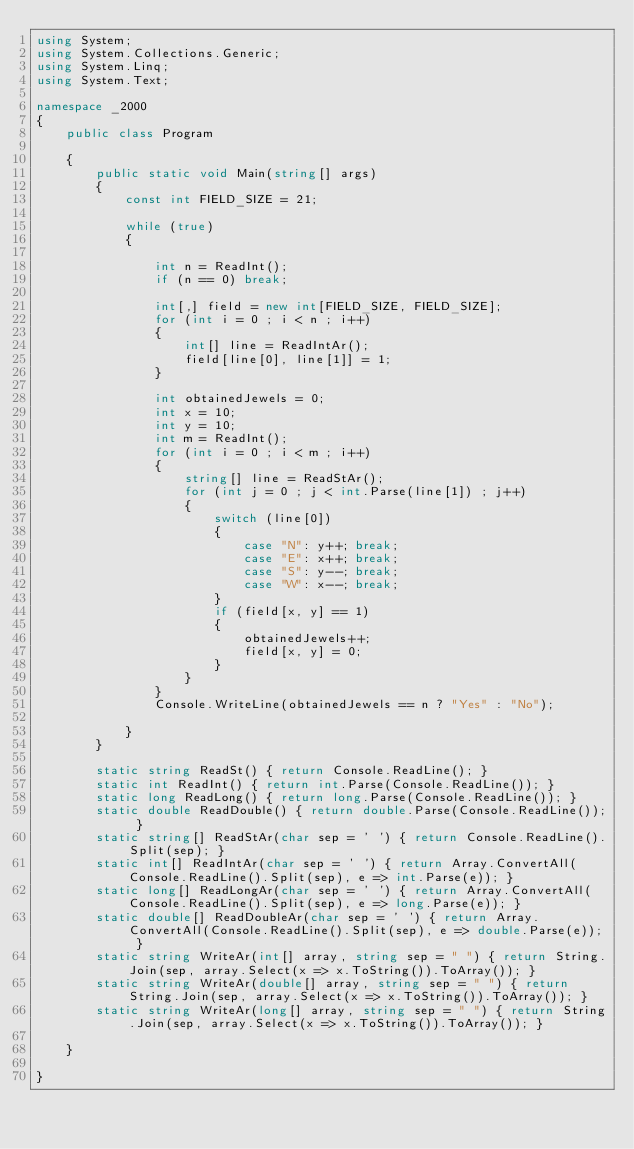Convert code to text. <code><loc_0><loc_0><loc_500><loc_500><_C#_>using System;
using System.Collections.Generic;
using System.Linq;
using System.Text;

namespace _2000
{
    public class Program

    {
        public static void Main(string[] args)
        {
            const int FIELD_SIZE = 21;

            while (true)
            {

                int n = ReadInt();
                if (n == 0) break;

                int[,] field = new int[FIELD_SIZE, FIELD_SIZE];
                for (int i = 0 ; i < n ; i++)
                {
                    int[] line = ReadIntAr();
                    field[line[0], line[1]] = 1;
                }

                int obtainedJewels = 0;
                int x = 10;
                int y = 10;
                int m = ReadInt();
                for (int i = 0 ; i < m ; i++)
                {
                    string[] line = ReadStAr();
                    for (int j = 0 ; j < int.Parse(line[1]) ; j++)
                    {
                        switch (line[0])
                        {
                            case "N": y++; break;
                            case "E": x++; break;
                            case "S": y--; break;
                            case "W": x--; break;
                        }
                        if (field[x, y] == 1)
                        {
                            obtainedJewels++;
                            field[x, y] = 0;
                        }
                    }
                }
                Console.WriteLine(obtainedJewels == n ? "Yes" : "No");

            }
        }

        static string ReadSt() { return Console.ReadLine(); }
        static int ReadInt() { return int.Parse(Console.ReadLine()); }
        static long ReadLong() { return long.Parse(Console.ReadLine()); }
        static double ReadDouble() { return double.Parse(Console.ReadLine()); }
        static string[] ReadStAr(char sep = ' ') { return Console.ReadLine().Split(sep); }
        static int[] ReadIntAr(char sep = ' ') { return Array.ConvertAll(Console.ReadLine().Split(sep), e => int.Parse(e)); }
        static long[] ReadLongAr(char sep = ' ') { return Array.ConvertAll(Console.ReadLine().Split(sep), e => long.Parse(e)); }
        static double[] ReadDoubleAr(char sep = ' ') { return Array.ConvertAll(Console.ReadLine().Split(sep), e => double.Parse(e)); }
        static string WriteAr(int[] array, string sep = " ") { return String.Join(sep, array.Select(x => x.ToString()).ToArray()); }
        static string WriteAr(double[] array, string sep = " ") { return String.Join(sep, array.Select(x => x.ToString()).ToArray()); }
        static string WriteAr(long[] array, string sep = " ") { return String.Join(sep, array.Select(x => x.ToString()).ToArray()); }

    }

}

</code> 